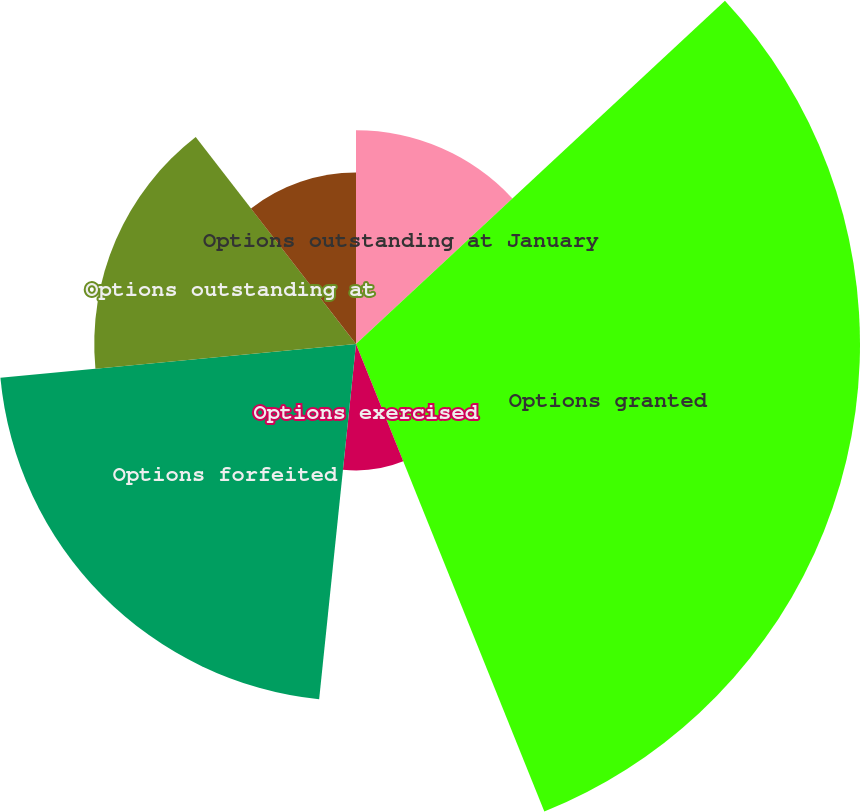Convert chart. <chart><loc_0><loc_0><loc_500><loc_500><pie_chart><fcel>Options outstanding at January<fcel>Options granted<fcel>Options exercised<fcel>Options forfeited<fcel>Options outstanding at<fcel>Number of options exercisable<nl><fcel>13.07%<fcel>30.83%<fcel>7.74%<fcel>21.85%<fcel>16.01%<fcel>10.49%<nl></chart> 